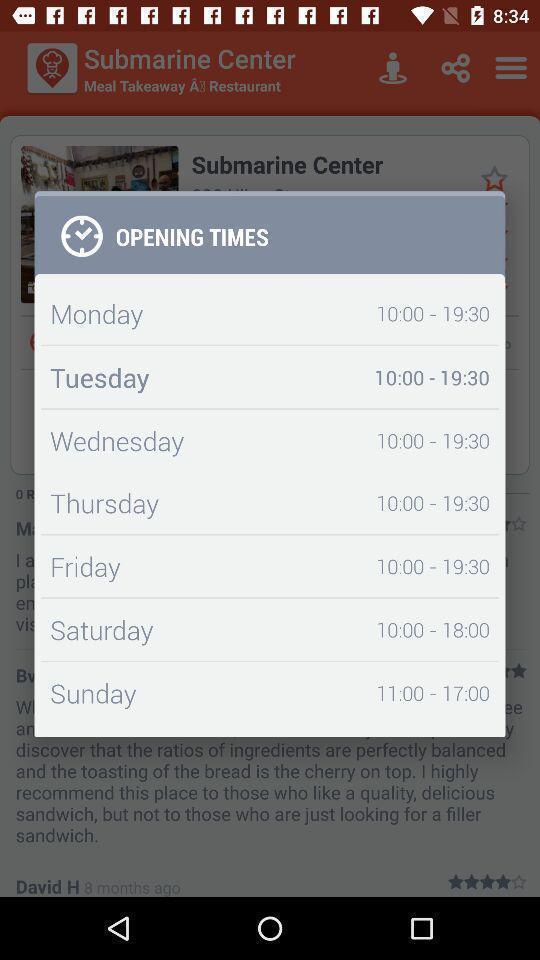What details can you identify in this image? Popup showing information about opening times. 